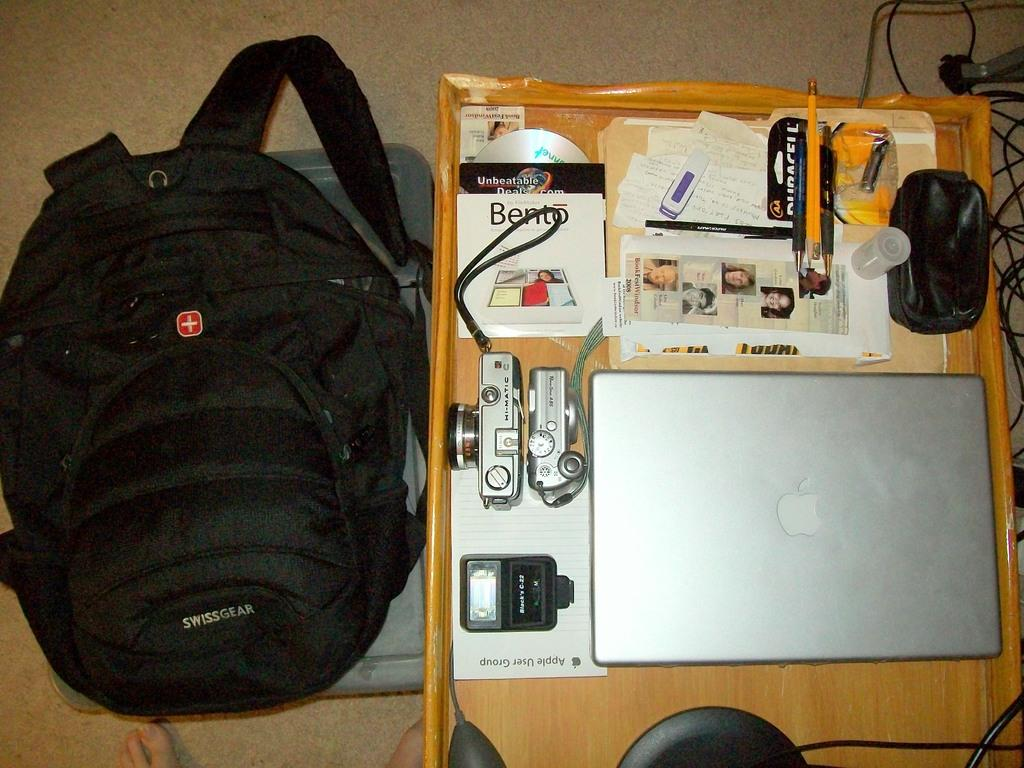Provide a one-sentence caption for the provided image. A computer sits on a small table near an Unbeatable Deals advertisement. 